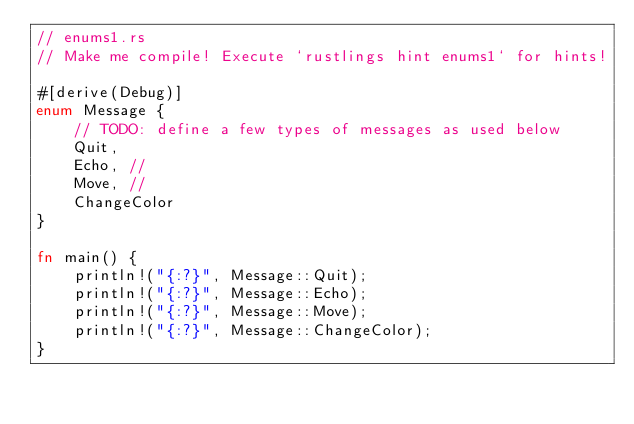<code> <loc_0><loc_0><loc_500><loc_500><_Rust_>// enums1.rs
// Make me compile! Execute `rustlings hint enums1` for hints!

#[derive(Debug)]
enum Message {
    // TODO: define a few types of messages as used below
    Quit,
    Echo, //
    Move, //
    ChangeColor
}

fn main() {
    println!("{:?}", Message::Quit);
    println!("{:?}", Message::Echo);
    println!("{:?}", Message::Move);
    println!("{:?}", Message::ChangeColor);
}
</code> 